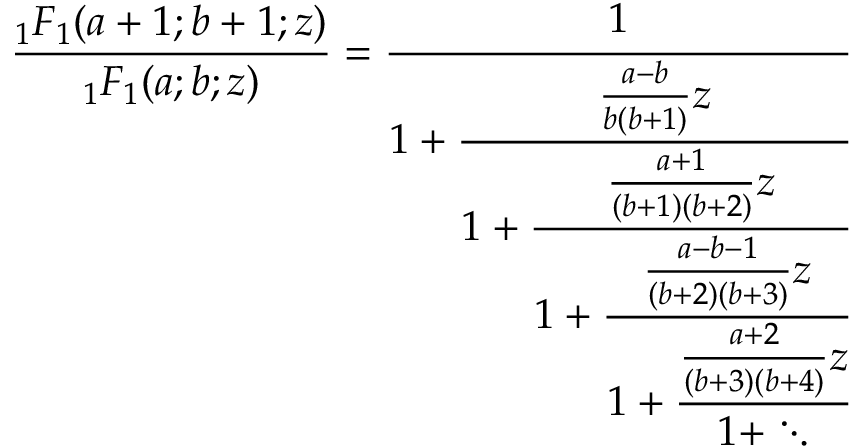Convert formula to latex. <formula><loc_0><loc_0><loc_500><loc_500>{ \frac { _ { 1 } F _ { 1 } ( a + 1 ; b + 1 ; z ) } { _ { 1 } F _ { 1 } ( a ; b ; z ) } } = { \cfrac { 1 } { 1 + { \cfrac { { \frac { a - b } { b ( b + 1 ) } } z } { 1 + { \cfrac { { \frac { a + 1 } { ( b + 1 ) ( b + 2 ) } } z } { 1 + { \cfrac { { \frac { a - b - 1 } { ( b + 2 ) ( b + 3 ) } } z } { 1 + { \cfrac { { \frac { a + 2 } { ( b + 3 ) ( b + 4 ) } } z } { 1 + \ddots } } } } } } } } } }</formula> 